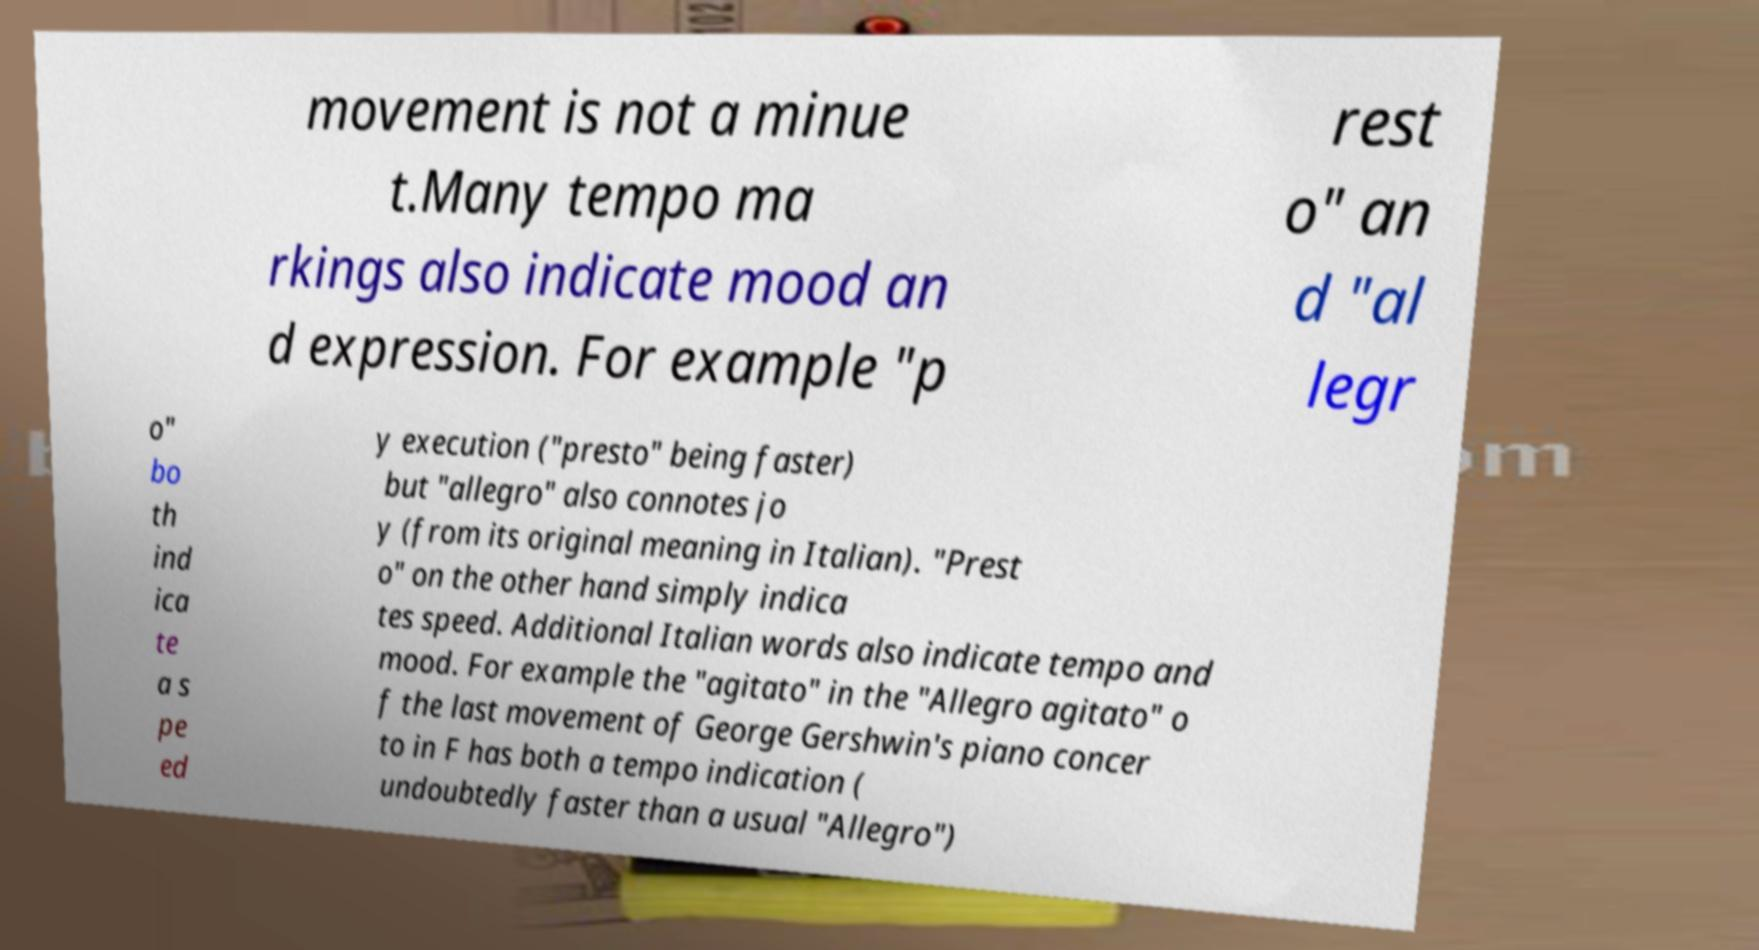Can you read and provide the text displayed in the image?This photo seems to have some interesting text. Can you extract and type it out for me? movement is not a minue t.Many tempo ma rkings also indicate mood an d expression. For example "p rest o" an d "al legr o" bo th ind ica te a s pe ed y execution ("presto" being faster) but "allegro" also connotes jo y (from its original meaning in Italian). "Prest o" on the other hand simply indica tes speed. Additional Italian words also indicate tempo and mood. For example the "agitato" in the "Allegro agitato" o f the last movement of George Gershwin's piano concer to in F has both a tempo indication ( undoubtedly faster than a usual "Allegro") 